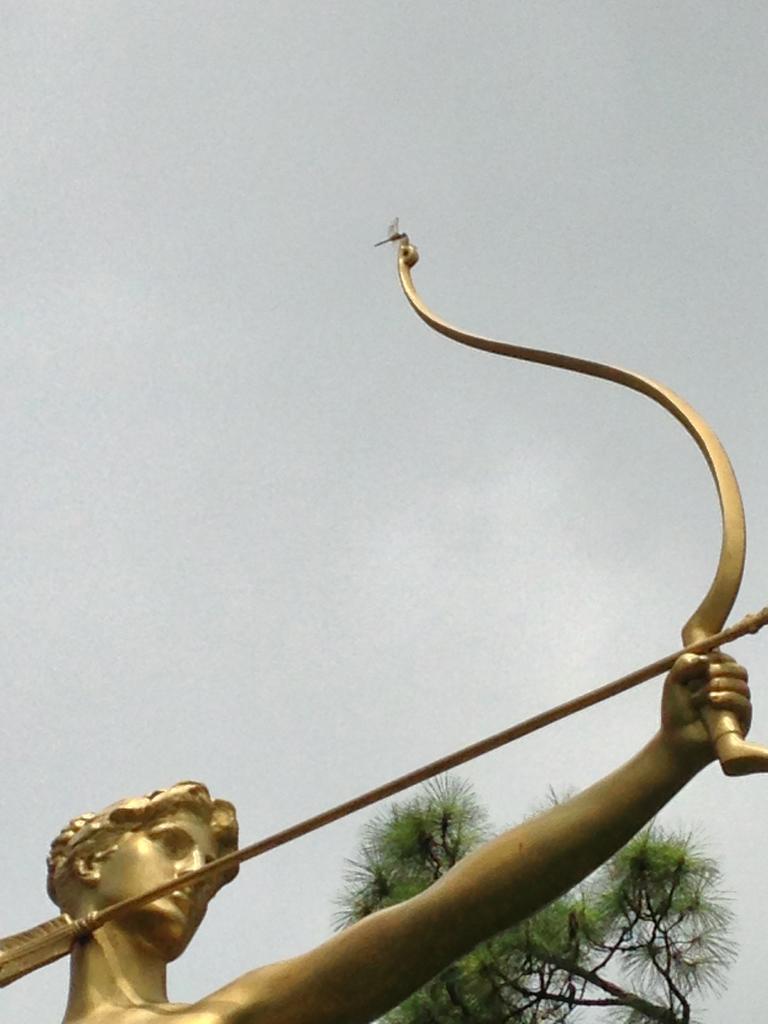How would you summarize this image in a sentence or two? In this image, this looks like the sky. At the bottom of the image, I can see a sculpture of a person holding a bow and arrow. This is a tree. 